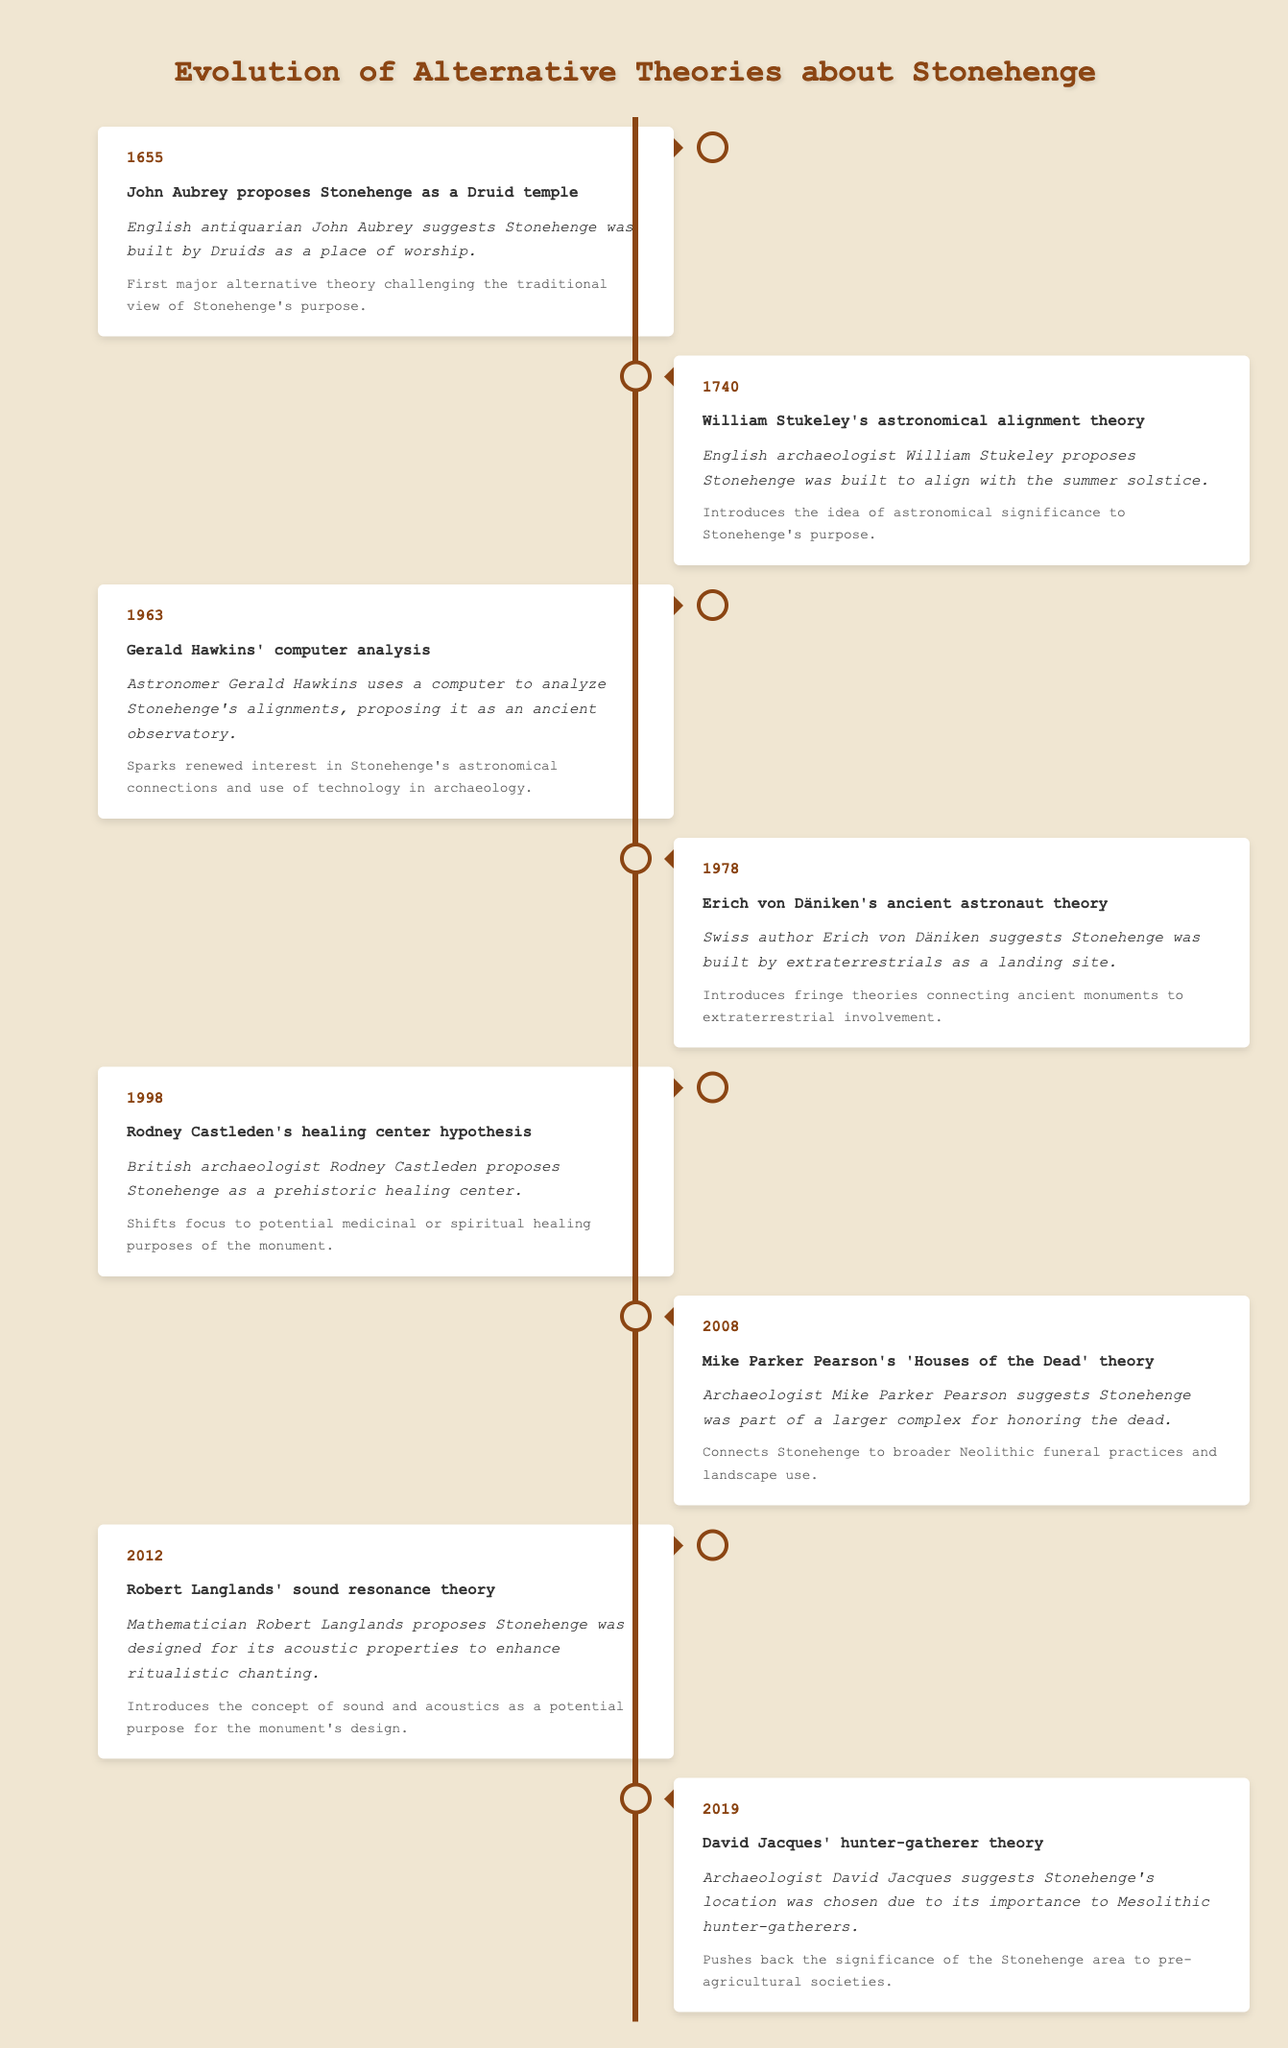What year did John Aubrey propose that Stonehenge was a Druid temple? In the table, John Aubrey's proposal is listed under the year 1655, making it easy to retrieve the specific year he made this suggestion.
Answer: 1655 What is the significance of William Stukeley's astronomical alignment theory? The table states that Stukeley's theory "introduces the idea of astronomical significance to Stonehenge's purpose," directly answering the significance of his proposal.
Answer: Introduces the idea of astronomical significance What event occurred right before Erich von Däniken's ancient astronaut theory? The event right before Däniken's theory in the timeline is Rodney Castleden's healing center hypothesis in 1998, which is one year earlier than Däniken's theory from 1978.
Answer: Rodney Castleden's healing center hypothesis in 1998 True or False: Robert Langlands proposed that Stonehenge was built for agricultural purposes. The table does not provide information indicating the agriculture as a purpose or theory by Robert Langlands, it specifies that he proposed it was for its acoustic properties to enhance ritualistic chanting. Thus, the statement is false.
Answer: False How many theories were proposed about Stonehenge from the 20th century onward? The timeline lists five events from 1963 onward: Hawkins' analysis (1963), von Däniken's theory (1978), Castleden's hypothesis (1998), Pearson's theory (2008), and Langlands' theory (2012). Sum up the total gives us five theories.
Answer: Five theories What is the relationship between Mike Parker Pearson's theory and the significance of hunter-gatherers? Parker Pearson's theory connects Stonehenge to broader Neolithic funeral practices but does not directly mention hunter-gatherers, which are discussed in David Jacques' theory in 2019 that precedes Parker Pearson's proposal. Therefore, both theories explore different cultural practices related to Stonehenge but emphasize distinct timelines and contexts.
Answer: They explore different cultural practices but emphasize distinct timelines What was the primary focus of Rodney Castleden's hypothesis in 1998? According to the table, Rodney Castleden's hypothesis proposed that Stonehenge served as a prehistoric healing center, indicating a focus on medicinal or spiritual purposes rather than its alignment or astronomical features.
Answer: Prehistoric healing center Which theory introduced a unique concept of sound as a purpose for Stonehenge? The table indicates that Robert Langlands introduced the idea that Stonehenge was designed for its acoustic properties to enhance ritualistic chanting, making this a distinct purpose among the theories presented.
Answer: Robert Langlands' sound resonance theory 